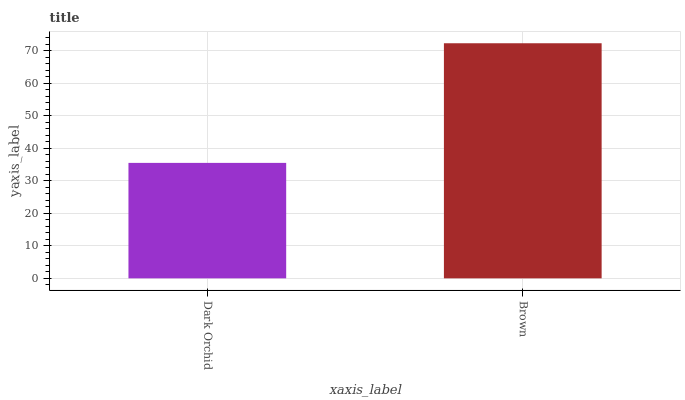Is Dark Orchid the minimum?
Answer yes or no. Yes. Is Brown the maximum?
Answer yes or no. Yes. Is Brown the minimum?
Answer yes or no. No. Is Brown greater than Dark Orchid?
Answer yes or no. Yes. Is Dark Orchid less than Brown?
Answer yes or no. Yes. Is Dark Orchid greater than Brown?
Answer yes or no. No. Is Brown less than Dark Orchid?
Answer yes or no. No. Is Brown the high median?
Answer yes or no. Yes. Is Dark Orchid the low median?
Answer yes or no. Yes. Is Dark Orchid the high median?
Answer yes or no. No. Is Brown the low median?
Answer yes or no. No. 